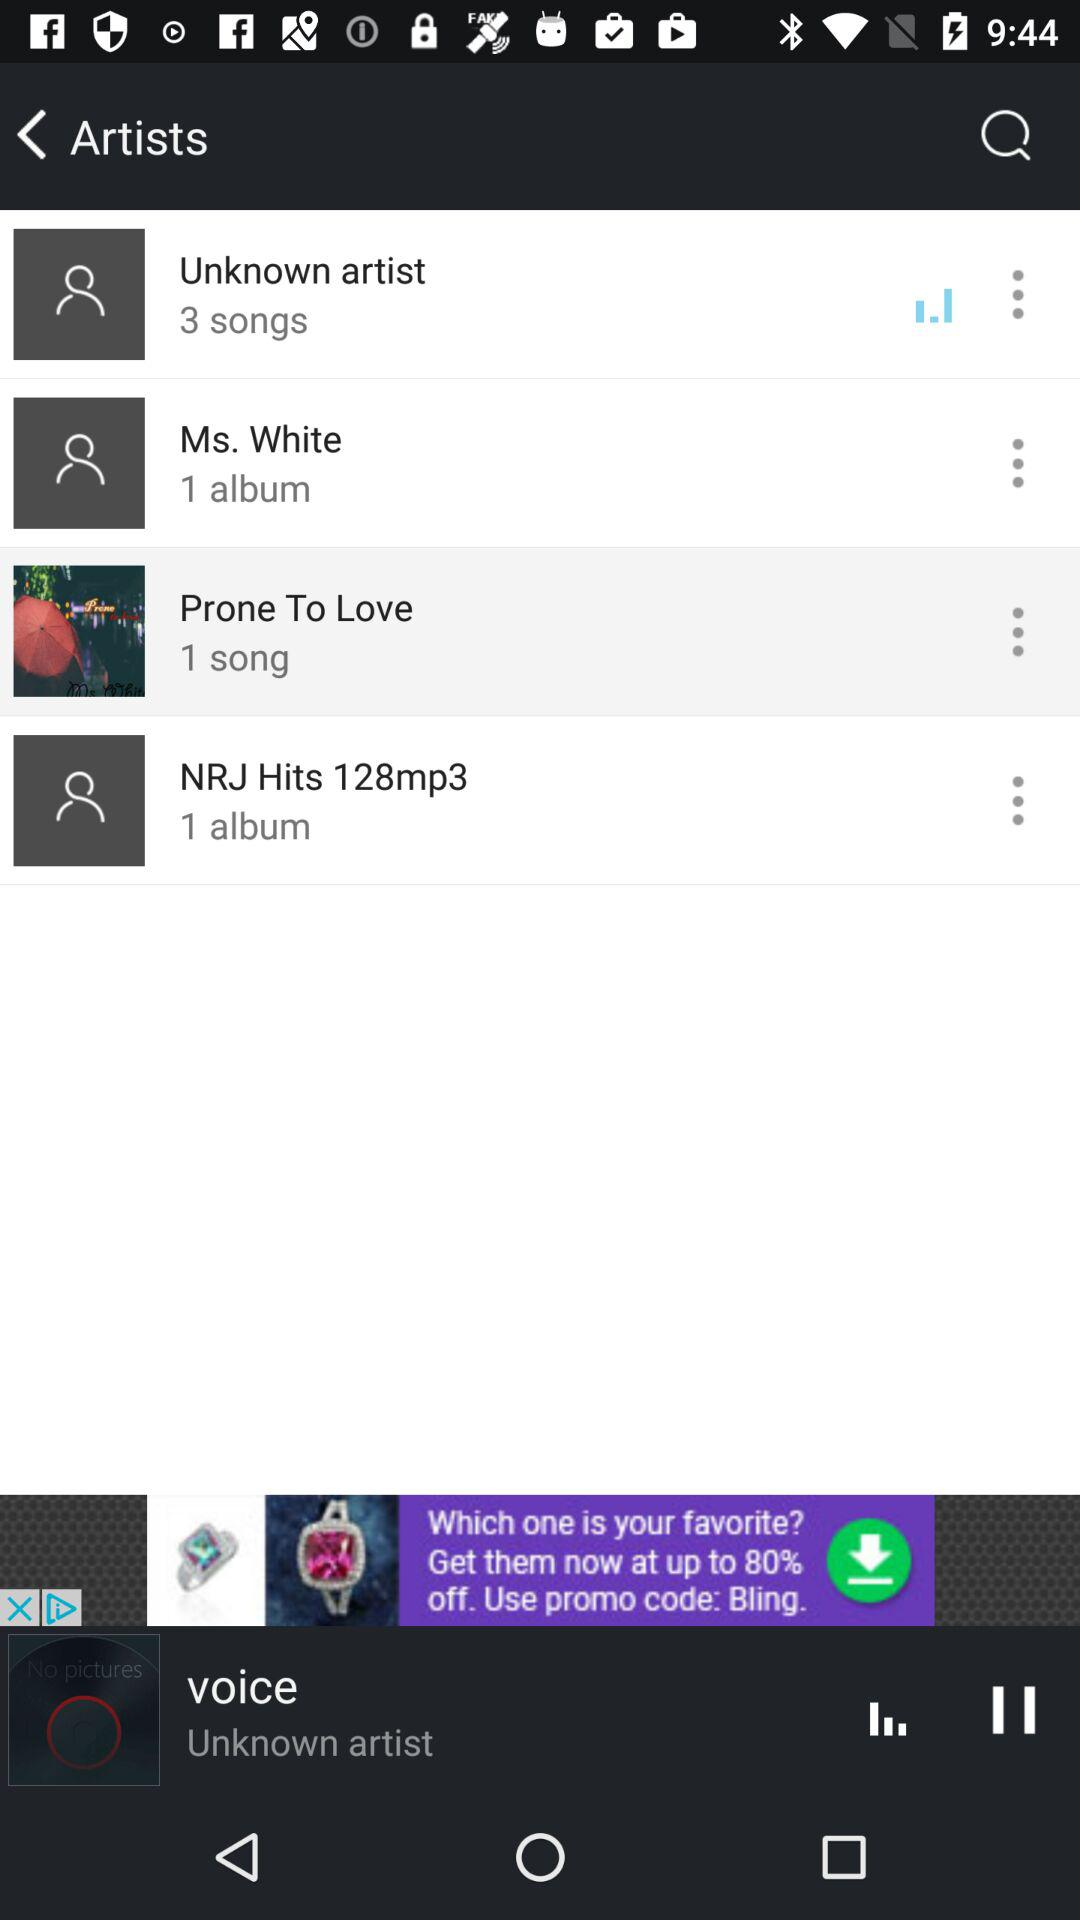What is the number of albums by Ms. White? The number of albums by Ms. White is 1. 